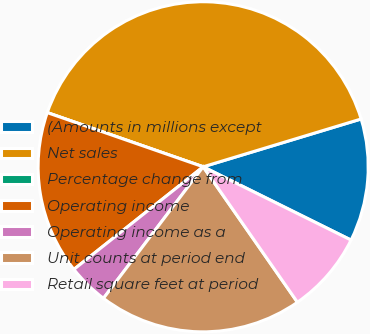<chart> <loc_0><loc_0><loc_500><loc_500><pie_chart><fcel>(Amounts in millions except<fcel>Net sales<fcel>Percentage change from<fcel>Operating income<fcel>Operating income as a<fcel>Unit counts at period end<fcel>Retail square feet at period<nl><fcel>12.0%<fcel>40.0%<fcel>0.0%<fcel>16.0%<fcel>4.0%<fcel>20.0%<fcel>8.0%<nl></chart> 